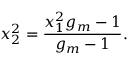<formula> <loc_0><loc_0><loc_500><loc_500>x _ { 2 } ^ { 2 } = \frac { x _ { 1 } ^ { 2 } g _ { m } - 1 } { g _ { m } - 1 } .</formula> 